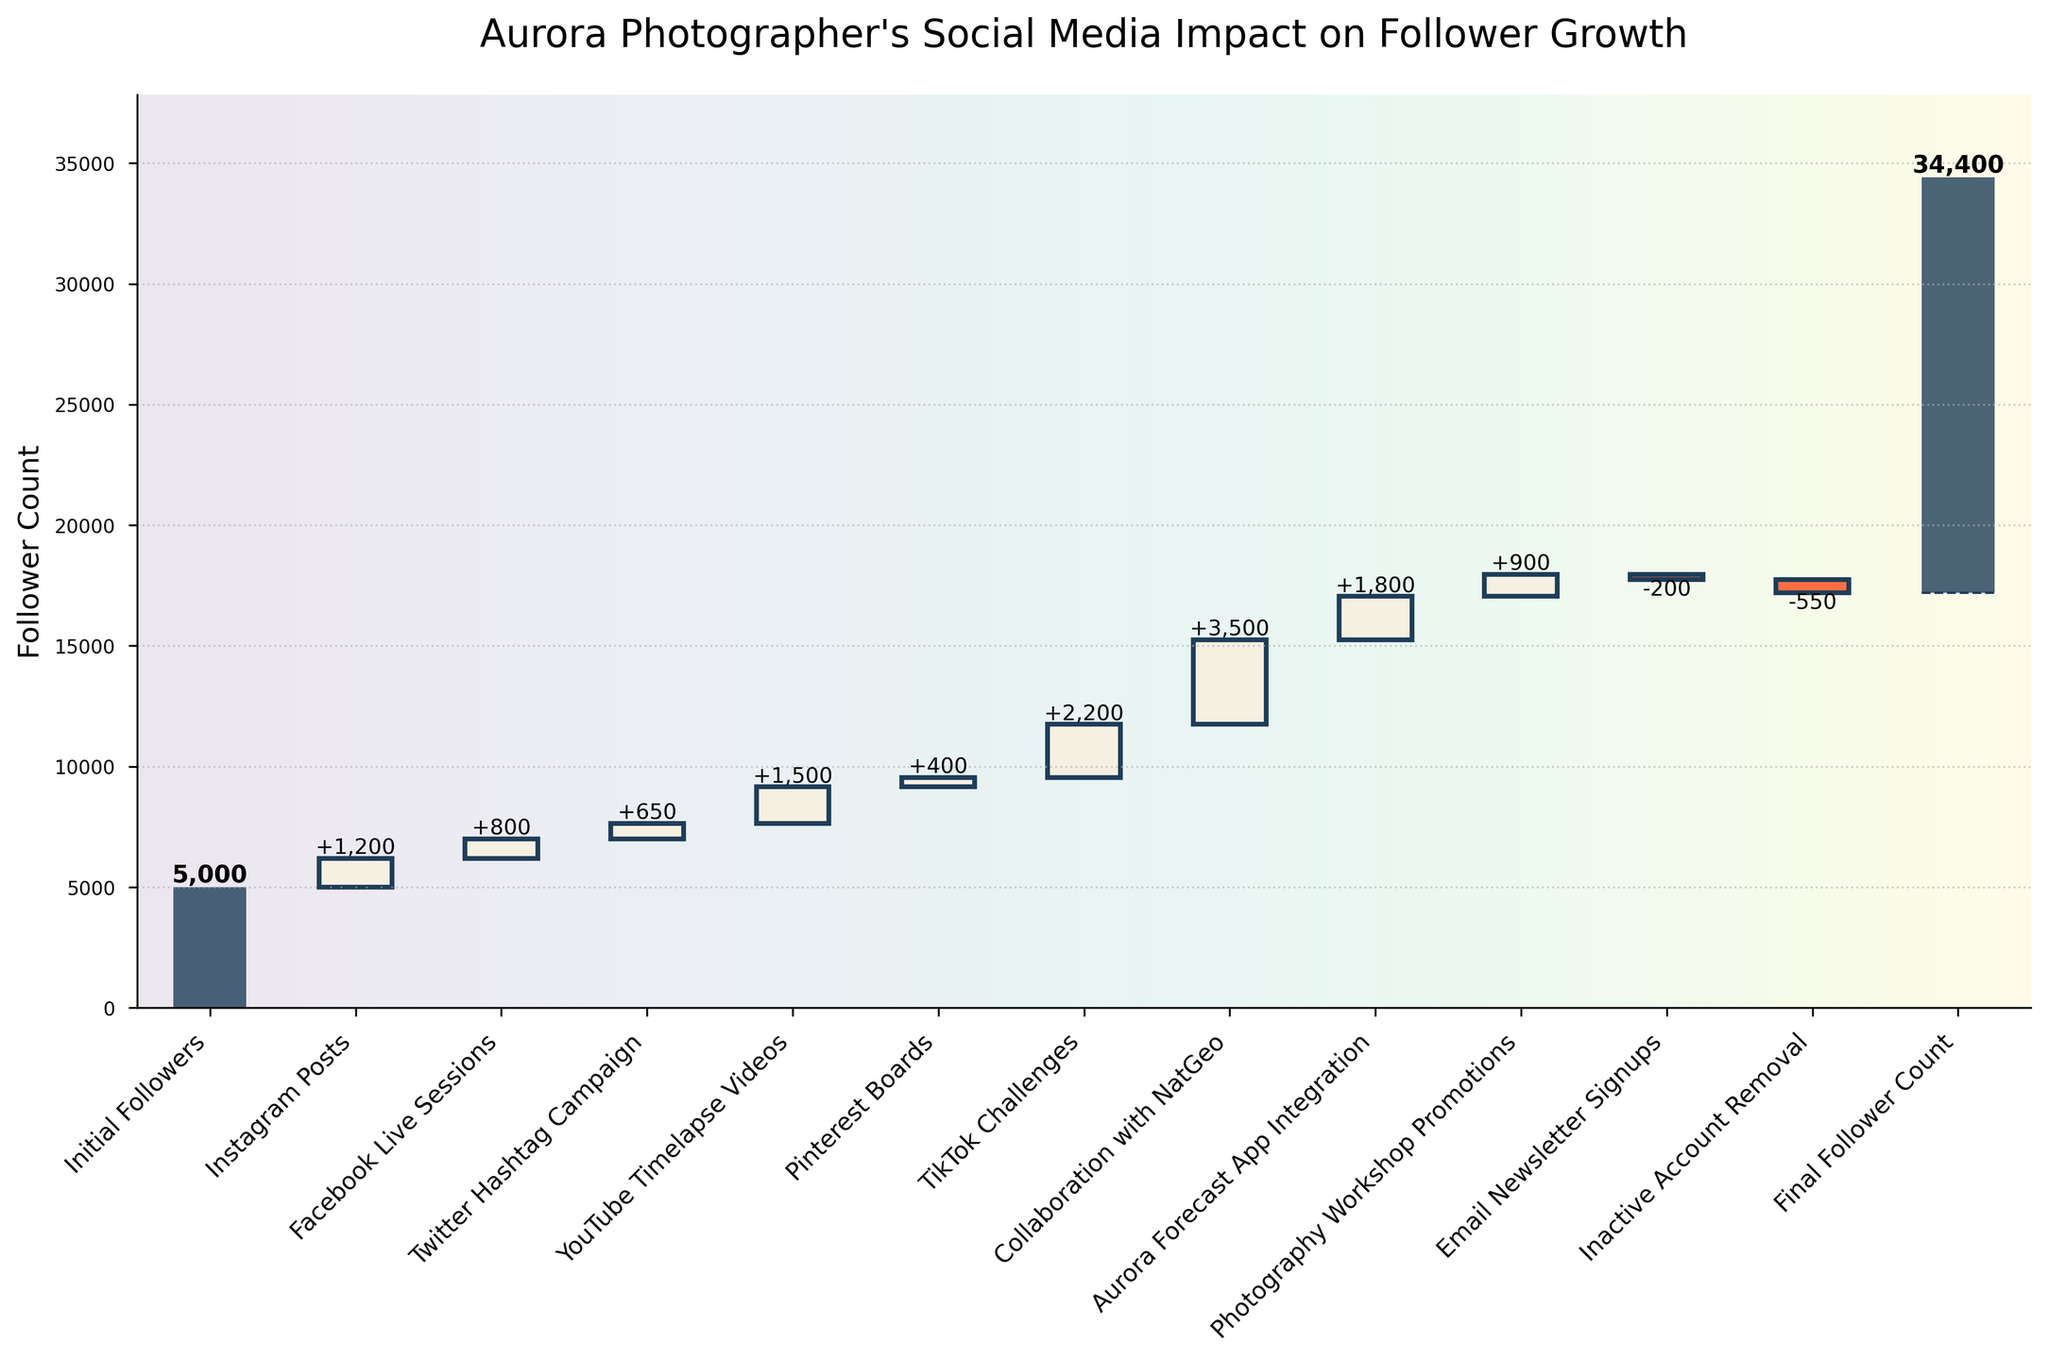How many categories are shown in the plot? Count the number of labels on the x-axis. There are 13 distinct categories including the initial and final follower counts.
Answer: 13 Which category contributed the most to follower growth during the campaign? Identify the category with the tallest positive bar. "Collaboration with NatGeo" shows the tallest bar, indicating the largest follower growth.
Answer: Collaboration with NatGeo How many categories showed a negative impact on follower growth? Count the number of bars below the x-axis. There are two negative bars: "Email Newsletter Signups" and "Inactive Account Removal".
Answer: 2 What is the net effect of inactive account removal on the follower count? Look at the value label for "Inactive Account Removal". It shows -550.
Answer: -550 What was the cumulative effect on the follower count before the "Collaboration with NatGeo" started? Sum the cumulative values up to and including the bar just before the "Collaboration with NatGeo" category. The cumulative sum before it is 8750.
Answer: 8750 Which category had the smallest positive impact on the follower count? Identify the smallest positive bar above the x-axis. "Pinterest Boards" has the smallest positive bar corresponding to follower growth of 400.
Answer: Pinterest Boards What is the visual impact of the "Email Newsletter Signups" category on the cumulative follower count? Observe the bar directly for "Email Newsletter Signups". The bar is quite short and red, indicating a small negative impact of -200.
Answer: -200 Between "TikTok Challenges" and "Aurora Forecast App Integration", which category added more followers? Compare the heights or numerical values of "TikTok Challenges" and "Aurora Forecast App Integration". "TikTok Challenges" added 2200 followers, whereas "Aurora Forecast App Integration" added 1800 followers. Thus, "TikTok Challenges" added more.
Answer: TikTok Challenges What was the final follower count after the campaign? Look at the value assigned to the last category on the x-axis. The "Final Follower Count" is 17200.
Answer: 17200 What is the difference in the cumulative follower count before and after the "Photography Workshop Promotions"? Identify the cumulative counts before and after "Photography Workshop Promotions" and compute the difference. Cumulative count after "Aurora Forecast App Integration" is 14650 and after "Photography Workshop Promotions" is 15550. The difference is 15550 - 14650 = 900.
Answer: 900 